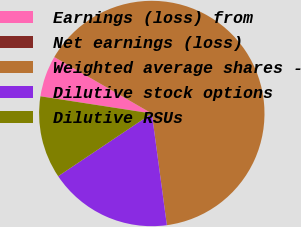Convert chart to OTSL. <chart><loc_0><loc_0><loc_500><loc_500><pie_chart><fcel>Earnings (loss) from<fcel>Net earnings (loss)<fcel>Weighted average shares -<fcel>Dilutive stock options<fcel>Dilutive RSUs<nl><fcel>5.91%<fcel>0.0%<fcel>64.51%<fcel>17.74%<fcel>11.83%<nl></chart> 